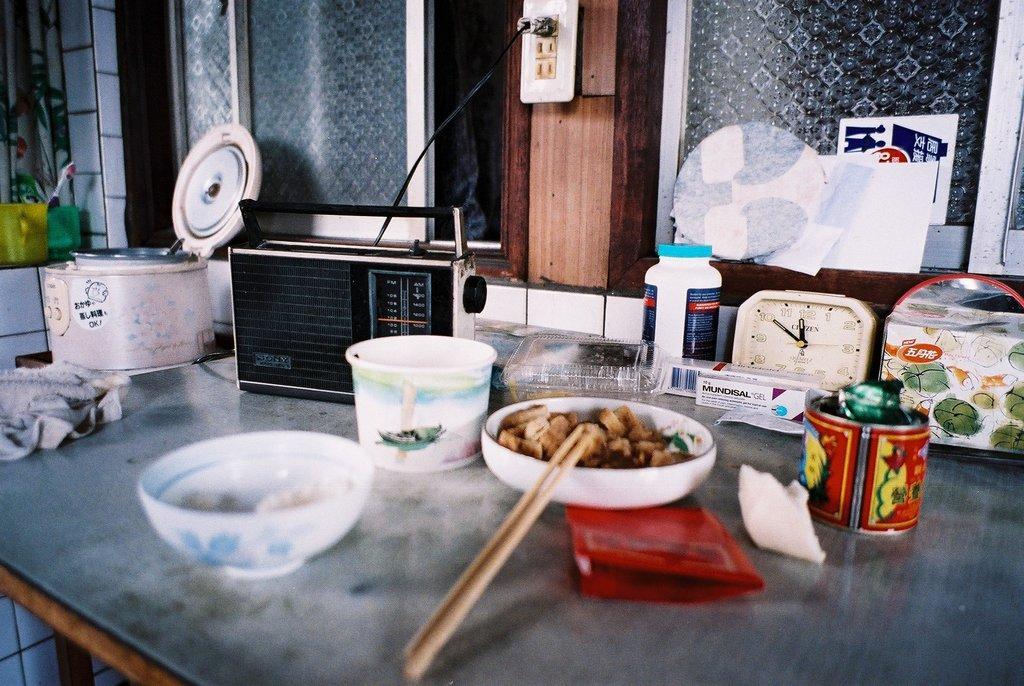In one or two sentences, can you explain what this image depicts? In this image we can see a table where a bowl, a radio, a cooker and watch are kept on it. Here we can see a glass window. 